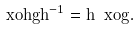Convert formula to latex. <formula><loc_0><loc_0><loc_500><loc_500>\ x o { h g h ^ { - 1 } } = h \ x o { g } .</formula> 